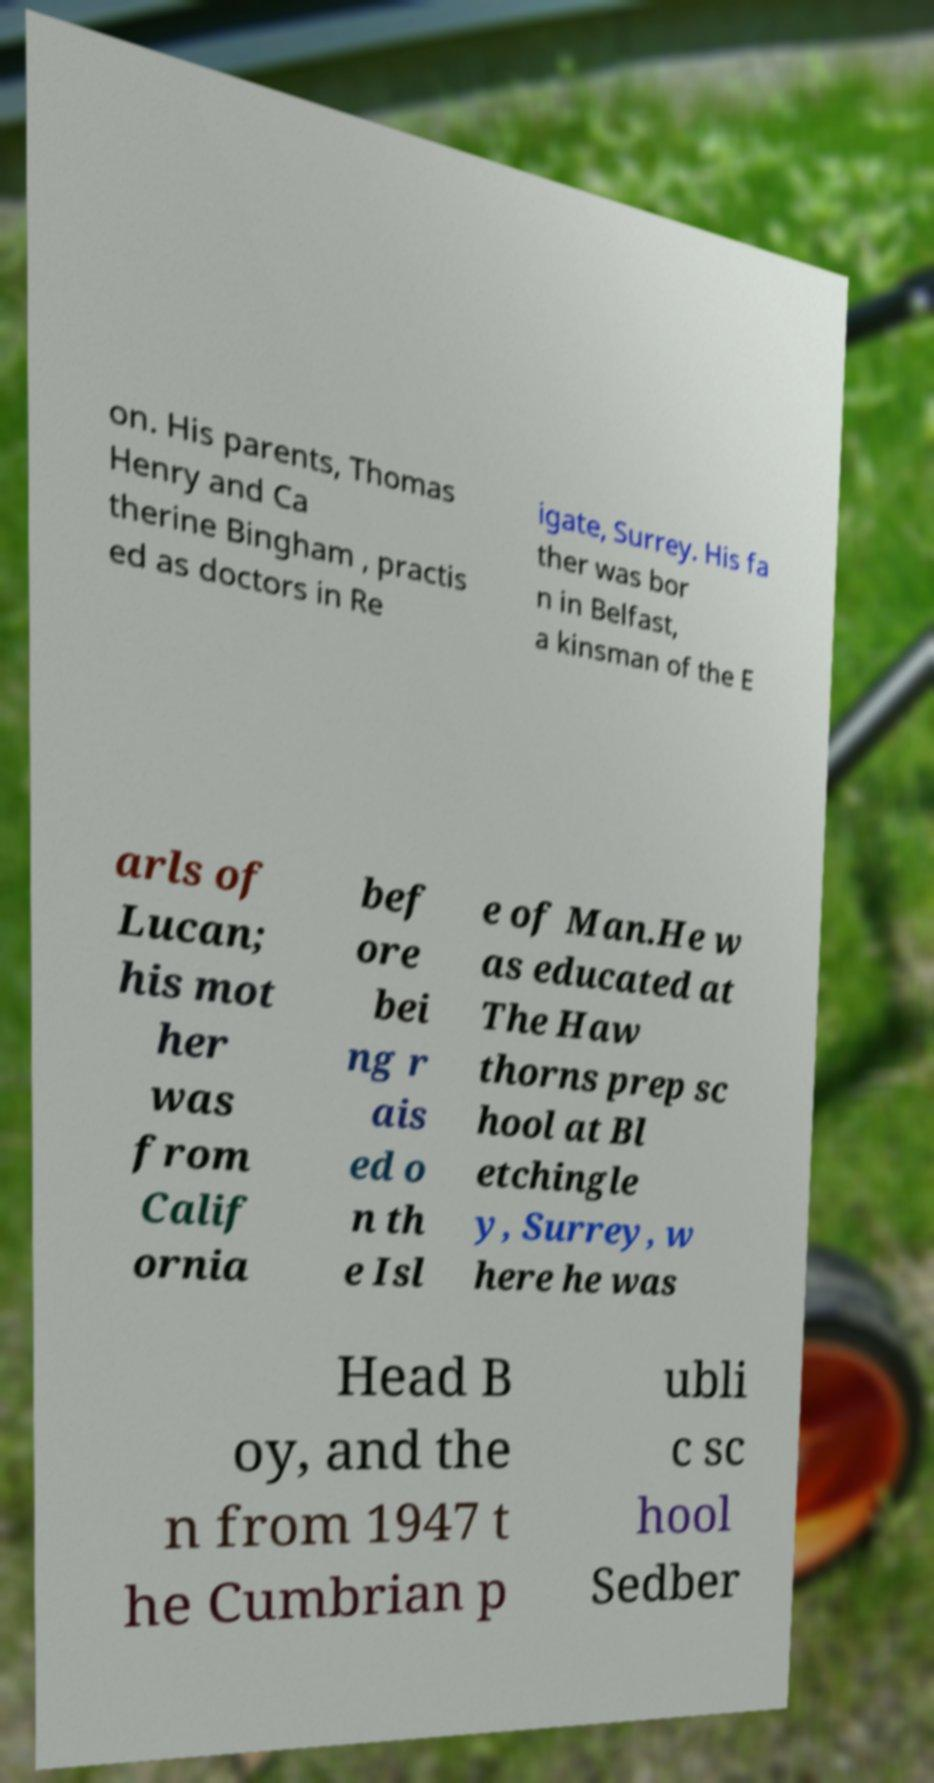Can you read and provide the text displayed in the image?This photo seems to have some interesting text. Can you extract and type it out for me? on. His parents, Thomas Henry and Ca therine Bingham , practis ed as doctors in Re igate, Surrey. His fa ther was bor n in Belfast, a kinsman of the E arls of Lucan; his mot her was from Calif ornia bef ore bei ng r ais ed o n th e Isl e of Man.He w as educated at The Haw thorns prep sc hool at Bl etchingle y, Surrey, w here he was Head B oy, and the n from 1947 t he Cumbrian p ubli c sc hool Sedber 